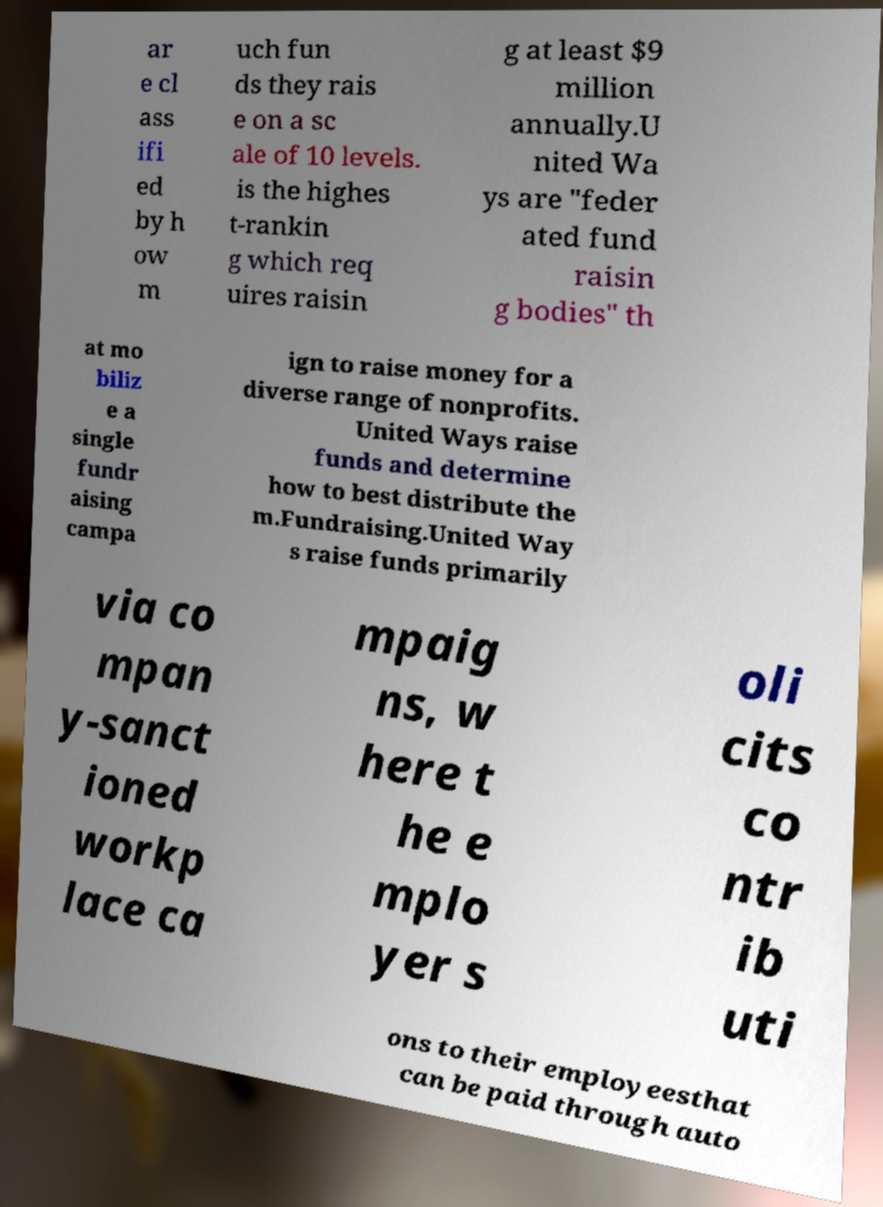Please read and relay the text visible in this image. What does it say? ar e cl ass ifi ed by h ow m uch fun ds they rais e on a sc ale of 10 levels. is the highes t-rankin g which req uires raisin g at least $9 million annually.U nited Wa ys are "feder ated fund raisin g bodies" th at mo biliz e a single fundr aising campa ign to raise money for a diverse range of nonprofits. United Ways raise funds and determine how to best distribute the m.Fundraising.United Way s raise funds primarily via co mpan y-sanct ioned workp lace ca mpaig ns, w here t he e mplo yer s oli cits co ntr ib uti ons to their employeesthat can be paid through auto 